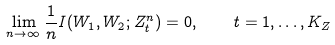Convert formula to latex. <formula><loc_0><loc_0><loc_500><loc_500>\lim _ { n \rightarrow \infty } \frac { 1 } { n } I ( W _ { 1 } , W _ { 2 } ; Z _ { t } ^ { n } ) = 0 , \quad t = 1 , \dots , K _ { Z }</formula> 